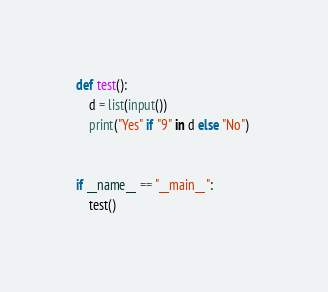<code> <loc_0><loc_0><loc_500><loc_500><_Python_>def test():
    d = list(input())
    print("Yes" if "9" in d else "No") 


if __name__ == "__main__":
    test()
</code> 